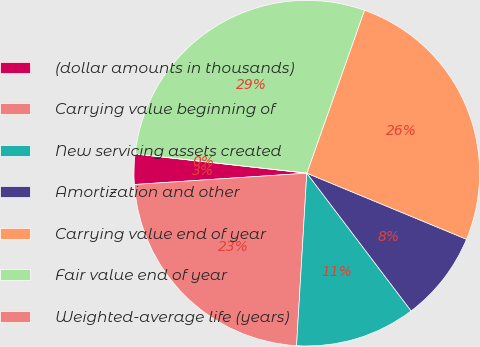Convert chart. <chart><loc_0><loc_0><loc_500><loc_500><pie_chart><fcel>(dollar amounts in thousands)<fcel>Carrying value beginning of<fcel>New servicing assets created<fcel>Amortization and other<fcel>Carrying value end of year<fcel>Fair value end of year<fcel>Weighted-average life (years)<nl><fcel>2.82%<fcel>23.01%<fcel>11.26%<fcel>8.44%<fcel>25.83%<fcel>28.64%<fcel>0.0%<nl></chart> 